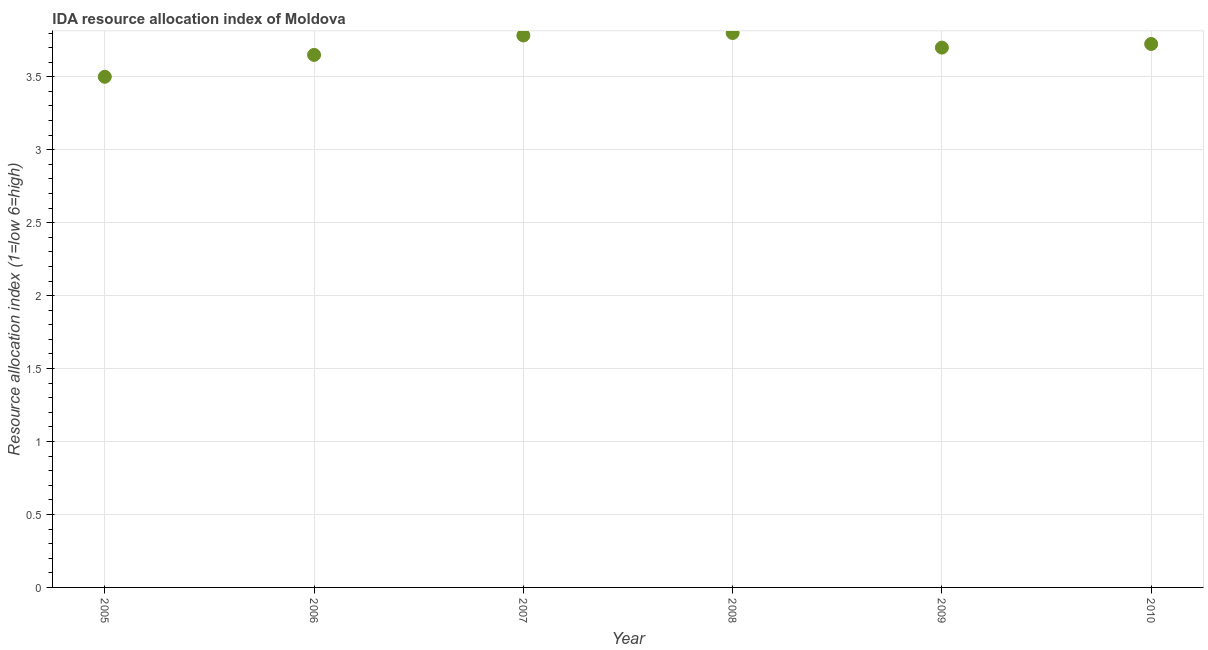What is the ida resource allocation index in 2006?
Provide a succinct answer. 3.65. What is the sum of the ida resource allocation index?
Ensure brevity in your answer.  22.16. What is the difference between the ida resource allocation index in 2006 and 2007?
Give a very brief answer. -0.13. What is the average ida resource allocation index per year?
Make the answer very short. 3.69. What is the median ida resource allocation index?
Keep it short and to the point. 3.71. What is the ratio of the ida resource allocation index in 2007 to that in 2008?
Provide a succinct answer. 1. Is the difference between the ida resource allocation index in 2006 and 2010 greater than the difference between any two years?
Provide a short and direct response. No. What is the difference between the highest and the second highest ida resource allocation index?
Keep it short and to the point. 0.02. What is the difference between the highest and the lowest ida resource allocation index?
Your answer should be compact. 0.3. Does the ida resource allocation index monotonically increase over the years?
Give a very brief answer. No. How many dotlines are there?
Your answer should be compact. 1. What is the difference between two consecutive major ticks on the Y-axis?
Your answer should be very brief. 0.5. Does the graph contain any zero values?
Ensure brevity in your answer.  No. What is the title of the graph?
Give a very brief answer. IDA resource allocation index of Moldova. What is the label or title of the Y-axis?
Provide a succinct answer. Resource allocation index (1=low 6=high). What is the Resource allocation index (1=low 6=high) in 2006?
Offer a terse response. 3.65. What is the Resource allocation index (1=low 6=high) in 2007?
Make the answer very short. 3.78. What is the Resource allocation index (1=low 6=high) in 2008?
Offer a very short reply. 3.8. What is the Resource allocation index (1=low 6=high) in 2009?
Provide a succinct answer. 3.7. What is the Resource allocation index (1=low 6=high) in 2010?
Your answer should be very brief. 3.73. What is the difference between the Resource allocation index (1=low 6=high) in 2005 and 2006?
Keep it short and to the point. -0.15. What is the difference between the Resource allocation index (1=low 6=high) in 2005 and 2007?
Your answer should be very brief. -0.28. What is the difference between the Resource allocation index (1=low 6=high) in 2005 and 2008?
Provide a succinct answer. -0.3. What is the difference between the Resource allocation index (1=low 6=high) in 2005 and 2009?
Your answer should be compact. -0.2. What is the difference between the Resource allocation index (1=low 6=high) in 2005 and 2010?
Provide a short and direct response. -0.23. What is the difference between the Resource allocation index (1=low 6=high) in 2006 and 2007?
Offer a very short reply. -0.13. What is the difference between the Resource allocation index (1=low 6=high) in 2006 and 2008?
Provide a succinct answer. -0.15. What is the difference between the Resource allocation index (1=low 6=high) in 2006 and 2010?
Keep it short and to the point. -0.07. What is the difference between the Resource allocation index (1=low 6=high) in 2007 and 2008?
Offer a terse response. -0.02. What is the difference between the Resource allocation index (1=low 6=high) in 2007 and 2009?
Your response must be concise. 0.08. What is the difference between the Resource allocation index (1=low 6=high) in 2007 and 2010?
Make the answer very short. 0.06. What is the difference between the Resource allocation index (1=low 6=high) in 2008 and 2010?
Your answer should be compact. 0.07. What is the difference between the Resource allocation index (1=low 6=high) in 2009 and 2010?
Your answer should be very brief. -0.03. What is the ratio of the Resource allocation index (1=low 6=high) in 2005 to that in 2006?
Make the answer very short. 0.96. What is the ratio of the Resource allocation index (1=low 6=high) in 2005 to that in 2007?
Keep it short and to the point. 0.93. What is the ratio of the Resource allocation index (1=low 6=high) in 2005 to that in 2008?
Provide a succinct answer. 0.92. What is the ratio of the Resource allocation index (1=low 6=high) in 2005 to that in 2009?
Your answer should be compact. 0.95. What is the ratio of the Resource allocation index (1=low 6=high) in 2007 to that in 2010?
Keep it short and to the point. 1.02. 